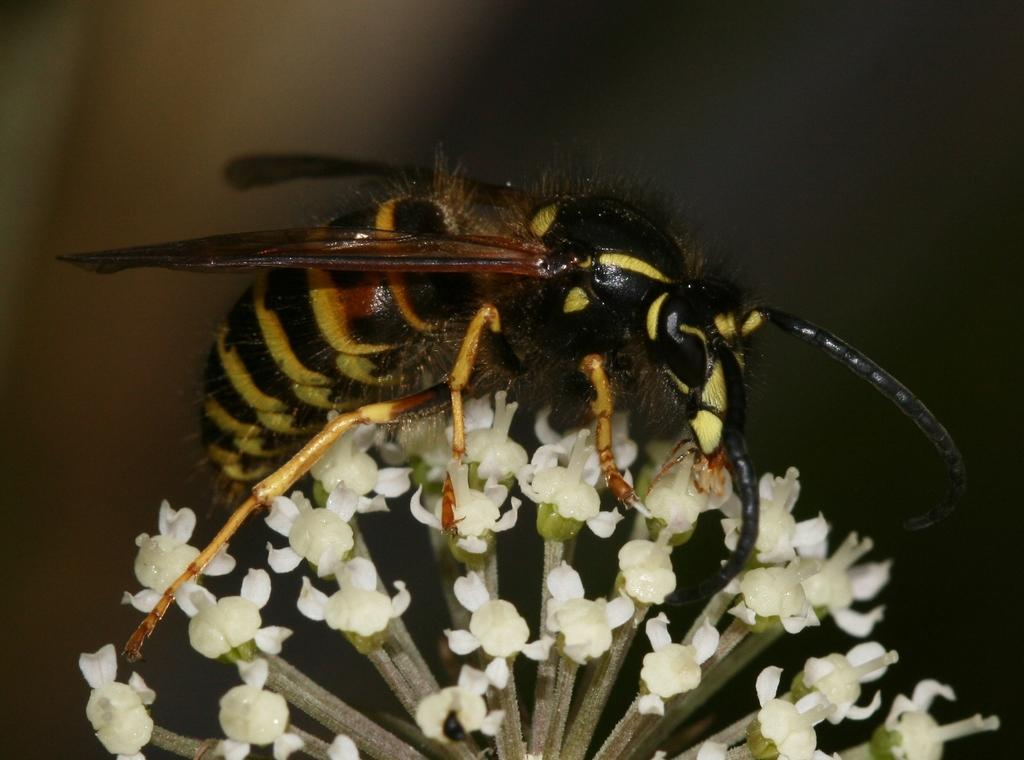What is the main subject of the image? There is an insect in the image. Where is the insect located? The insect is on flowers. Can you describe the background of the image? The background of the image is blurry. What type of respect can be seen in the image? There is no indication of respect in the image, as it features an insect on flowers with a blurry background. 